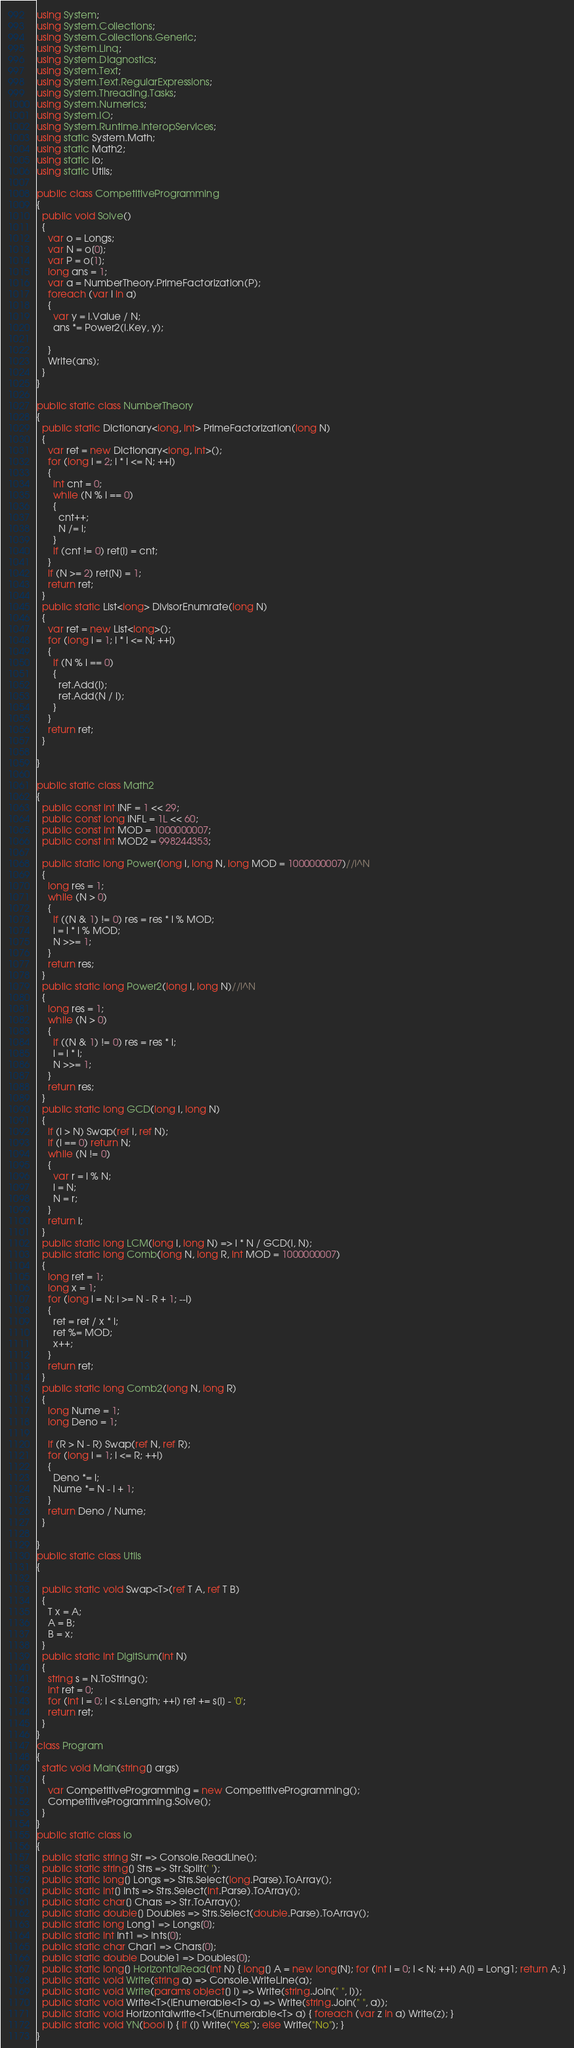Convert code to text. <code><loc_0><loc_0><loc_500><loc_500><_C#_>using System;
using System.Collections;
using System.Collections.Generic;
using System.Linq;
using System.Diagnostics;
using System.Text;
using System.Text.RegularExpressions;
using System.Threading.Tasks;
using System.Numerics;
using System.IO;
using System.Runtime.InteropServices;
using static System.Math;
using static Math2;
using static io;
using static Utils;

public class CompetitiveProgramming
{
  public void Solve()
  {
    var o = Longs;
    var N = o[0];
    var P = o[1];
    long ans = 1;
    var a = NumberTheory.PrimeFactorization(P);
    foreach (var i in a)
    {
      var y = i.Value / N;
      ans *= Power2(i.Key, y);

    }
    Write(ans);
  }
}

public static class NumberTheory
{
  public static Dictionary<long, int> PrimeFactorization(long N)
  {
    var ret = new Dictionary<long, int>();
    for (long i = 2; i * i <= N; ++i)
    {
      int cnt = 0;
      while (N % i == 0)
      {
        cnt++;
        N /= i;
      }
      if (cnt != 0) ret[i] = cnt;
    }
    if (N >= 2) ret[N] = 1;
    return ret;
  }
  public static List<long> DivisorEnumrate(long N)
  {
    var ret = new List<long>();
    for (long i = 1; i * i <= N; ++i)
    {
      if (N % i == 0)
      {
        ret.Add(i);
        ret.Add(N / i);
      }
    }
    return ret;
  }

}

public static class Math2
{
  public const int INF = 1 << 29;
  public const long INFL = 1L << 60;
  public const int MOD = 1000000007;
  public const int MOD2 = 998244353;

  public static long Power(long i, long N, long MOD = 1000000007)//i^N
  {
    long res = 1;
    while (N > 0)
    {
      if ((N & 1) != 0) res = res * i % MOD;
      i = i * i % MOD;
      N >>= 1;
    }
    return res;
  }
  public static long Power2(long i, long N)//i^N
  {
    long res = 1;
    while (N > 0)
    {
      if ((N & 1) != 0) res = res * i;
      i = i * i;
      N >>= 1;
    }
    return res;
  }
  public static long GCD(long i, long N)
  {
    if (i > N) Swap(ref i, ref N);
    if (i == 0) return N;
    while (N != 0)
    {
      var r = i % N;
      i = N;
      N = r;
    }
    return i;
  }
  public static long LCM(long i, long N) => i * N / GCD(i, N);
  public static long Comb(long N, long R, int MOD = 1000000007)
  {
    long ret = 1;
    long x = 1;
    for (long i = N; i >= N - R + 1; --i)
    {
      ret = ret / x * i;
      ret %= MOD;
      x++;
    }
    return ret;
  }
  public static long Comb2(long N, long R)
  {
    long Nume = 1;
    long Deno = 1;

    if (R > N - R) Swap(ref N, ref R);
    for (long i = 1; i <= R; ++i)
    {
      Deno *= i;
      Nume *= N - i + 1;
    }
    return Deno / Nume;
  }

}
public static class Utils
{

  public static void Swap<T>(ref T A, ref T B)
  {
    T x = A;
    A = B;
    B = x;
  }
  public static int DigitSum(int N)
  {
    string s = N.ToString();
    int ret = 0;
    for (int i = 0; i < s.Length; ++i) ret += s[i] - '0';
    return ret;
  }
}
class Program
{
  static void Main(string[] args)
  {
    var CompetitiveProgramming = new CompetitiveProgramming();
    CompetitiveProgramming.Solve();
  }
}
public static class io
{
  public static string Str => Console.ReadLine();
  public static string[] Strs => Str.Split(' ');
  public static long[] Longs => Strs.Select(long.Parse).ToArray();
  public static int[] Ints => Strs.Select(int.Parse).ToArray();
  public static char[] Chars => Str.ToArray();
  public static double[] Doubles => Strs.Select(double.Parse).ToArray();
  public static long Long1 => Longs[0];
  public static int Int1 => Ints[0];
  public static char Char1 => Chars[0];
  public static double Double1 => Doubles[0];
  public static long[] HorizontalRead(int N) { long[] A = new long[N]; for (int i = 0; i < N; ++i) A[i] = Long1; return A; }
  public static void Write(string a) => Console.WriteLine(a);
  public static void Write(params object[] i) => Write(string.Join(" ", i));
  public static void Write<T>(IEnumerable<T> a) => Write(string.Join(" ", a));
  public static void Horizontalwrite<T>(IEnumerable<T> a) { foreach (var z in a) Write(z); }
  public static void YN(bool i) { if (i) Write("Yes"); else Write("No"); }
}
</code> 